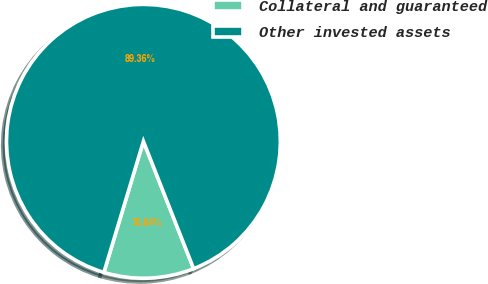Convert chart to OTSL. <chart><loc_0><loc_0><loc_500><loc_500><pie_chart><fcel>Collateral and guaranteed<fcel>Other invested assets<nl><fcel>10.64%<fcel>89.36%<nl></chart> 